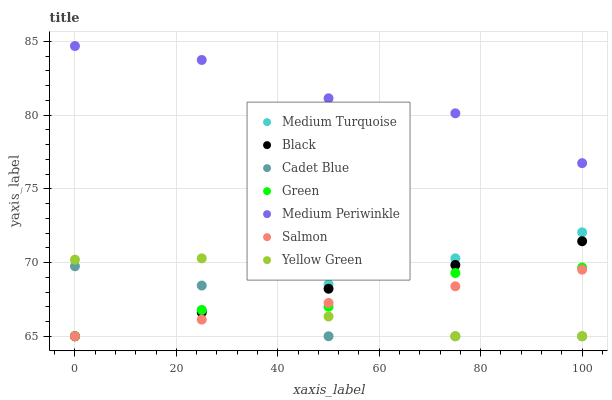Does Cadet Blue have the minimum area under the curve?
Answer yes or no. Yes. Does Medium Periwinkle have the maximum area under the curve?
Answer yes or no. Yes. Does Yellow Green have the minimum area under the curve?
Answer yes or no. No. Does Yellow Green have the maximum area under the curve?
Answer yes or no. No. Is Salmon the smoothest?
Answer yes or no. Yes. Is Yellow Green the roughest?
Answer yes or no. Yes. Is Medium Periwinkle the smoothest?
Answer yes or no. No. Is Medium Periwinkle the roughest?
Answer yes or no. No. Does Cadet Blue have the lowest value?
Answer yes or no. Yes. Does Medium Periwinkle have the lowest value?
Answer yes or no. No. Does Medium Periwinkle have the highest value?
Answer yes or no. Yes. Does Yellow Green have the highest value?
Answer yes or no. No. Is Green less than Medium Periwinkle?
Answer yes or no. Yes. Is Medium Periwinkle greater than Medium Turquoise?
Answer yes or no. Yes. Does Green intersect Yellow Green?
Answer yes or no. Yes. Is Green less than Yellow Green?
Answer yes or no. No. Is Green greater than Yellow Green?
Answer yes or no. No. Does Green intersect Medium Periwinkle?
Answer yes or no. No. 